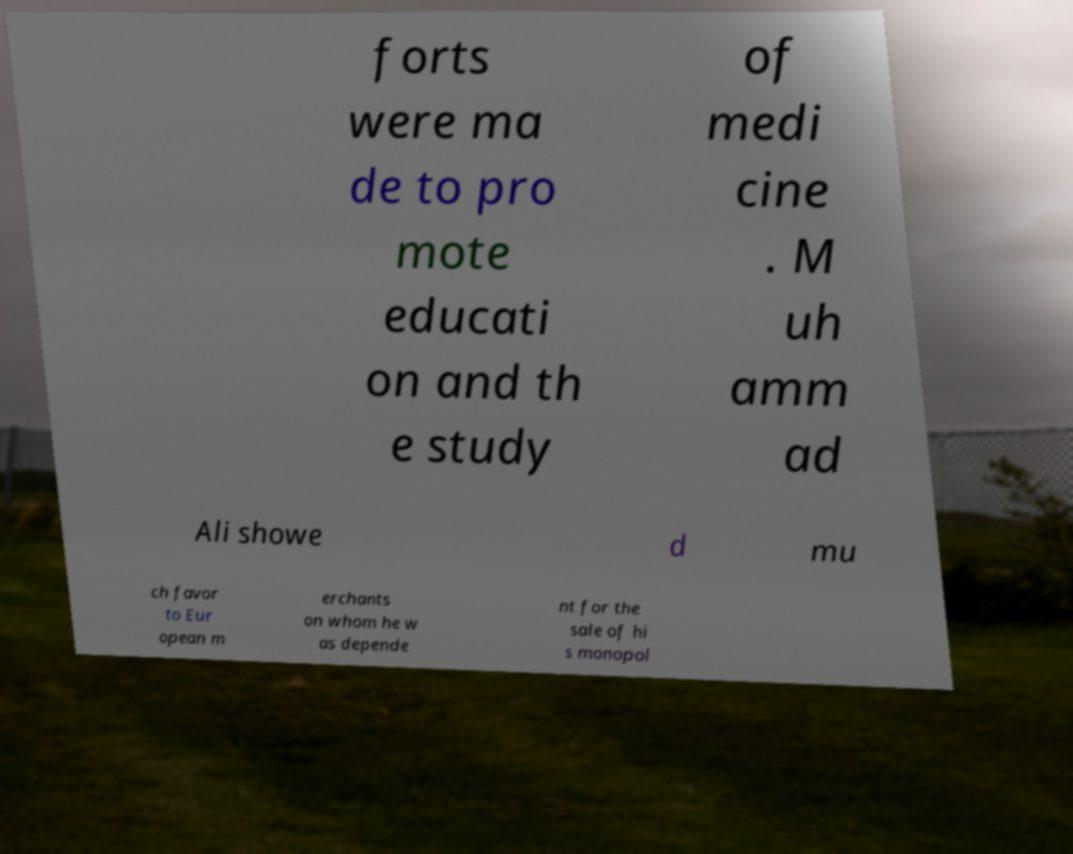For documentation purposes, I need the text within this image transcribed. Could you provide that? forts were ma de to pro mote educati on and th e study of medi cine . M uh amm ad Ali showe d mu ch favor to Eur opean m erchants on whom he w as depende nt for the sale of hi s monopol 